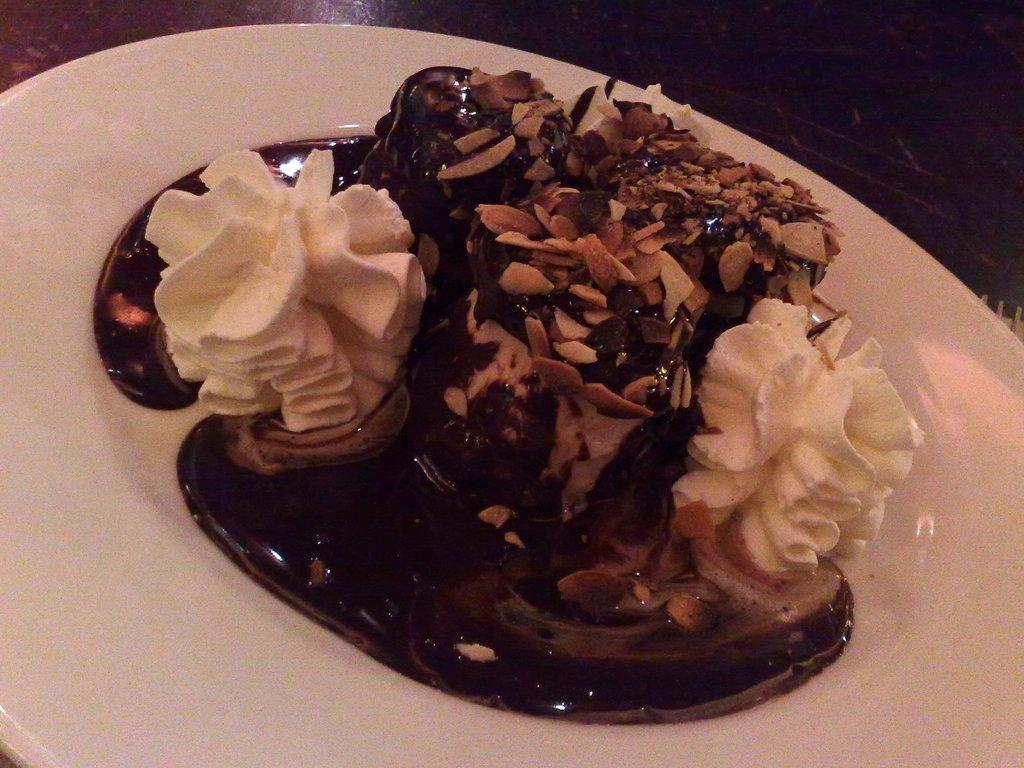What is on the plate in the image? There is a cake on the plate in the image. What is the color of the plate? The plate is white. What is on top of the cake? The cake has cream on it, and there are dry fruits on the cake. How many decisions were made in the process of creating the cake? There is no information in the image about the decisions made during the cake-making process. 